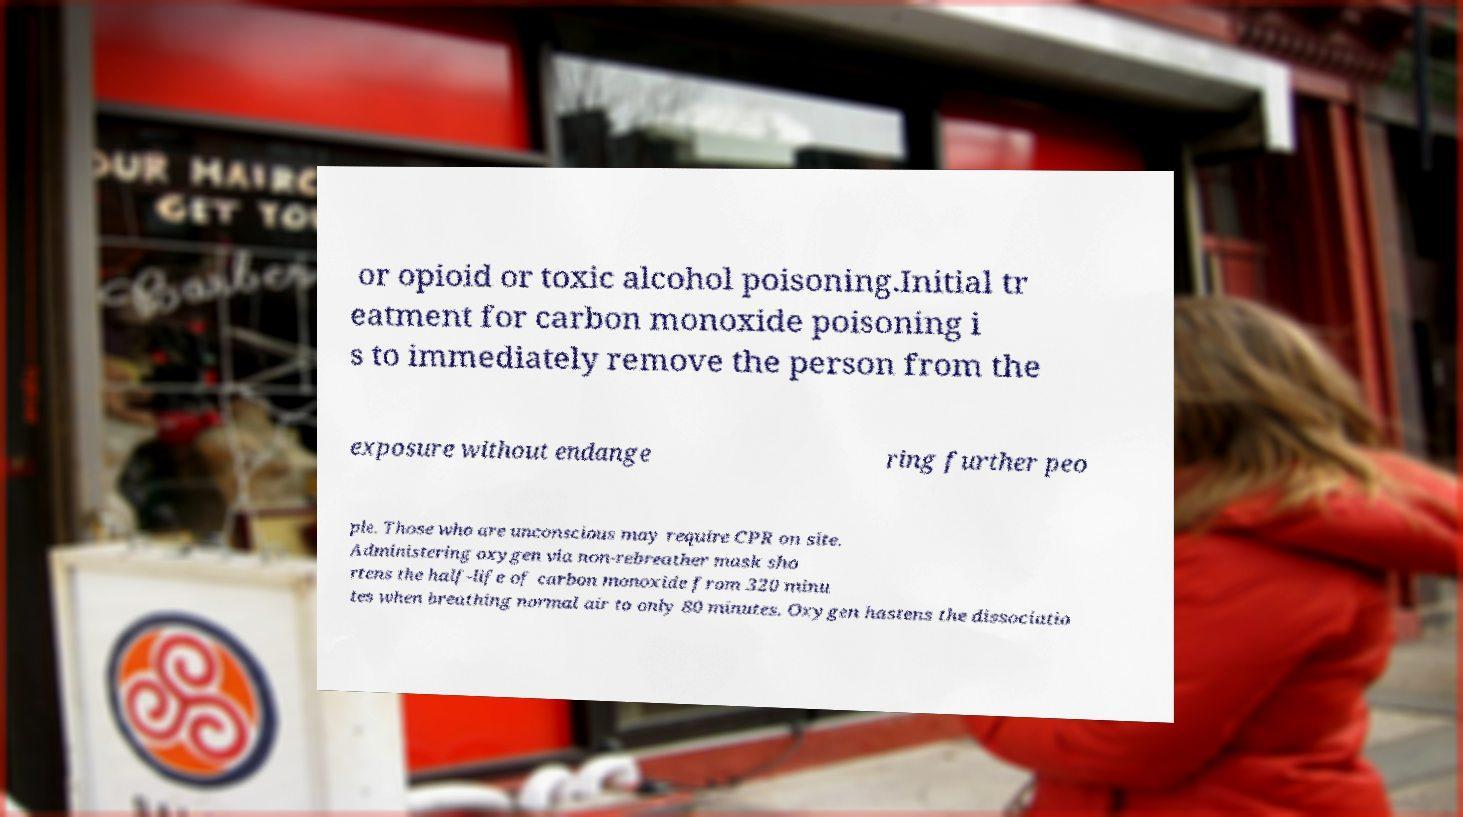Can you read and provide the text displayed in the image?This photo seems to have some interesting text. Can you extract and type it out for me? or opioid or toxic alcohol poisoning.Initial tr eatment for carbon monoxide poisoning i s to immediately remove the person from the exposure without endange ring further peo ple. Those who are unconscious may require CPR on site. Administering oxygen via non-rebreather mask sho rtens the half-life of carbon monoxide from 320 minu tes when breathing normal air to only 80 minutes. Oxygen hastens the dissociatio 